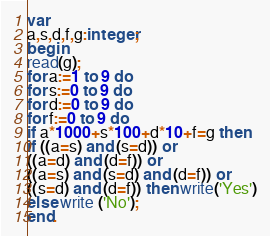Convert code to text. <code><loc_0><loc_0><loc_500><loc_500><_Pascal_>var
a,s,d,f,g:integer;
begin
read(g);
for a:=1 to 9 do
for s:=0 to 9 do
for d:=0 to 9 do
for f:=0 to 9 do
if a*1000+s*100+d*10+f=g then
if ((a=s) and (s=d)) or
((a=d) and (d=f)) or
((a=s) and (s=d) and (d=f)) or
((s=d) and (d=f)) then write('Yes')
else write ('No');
end.
</code> 